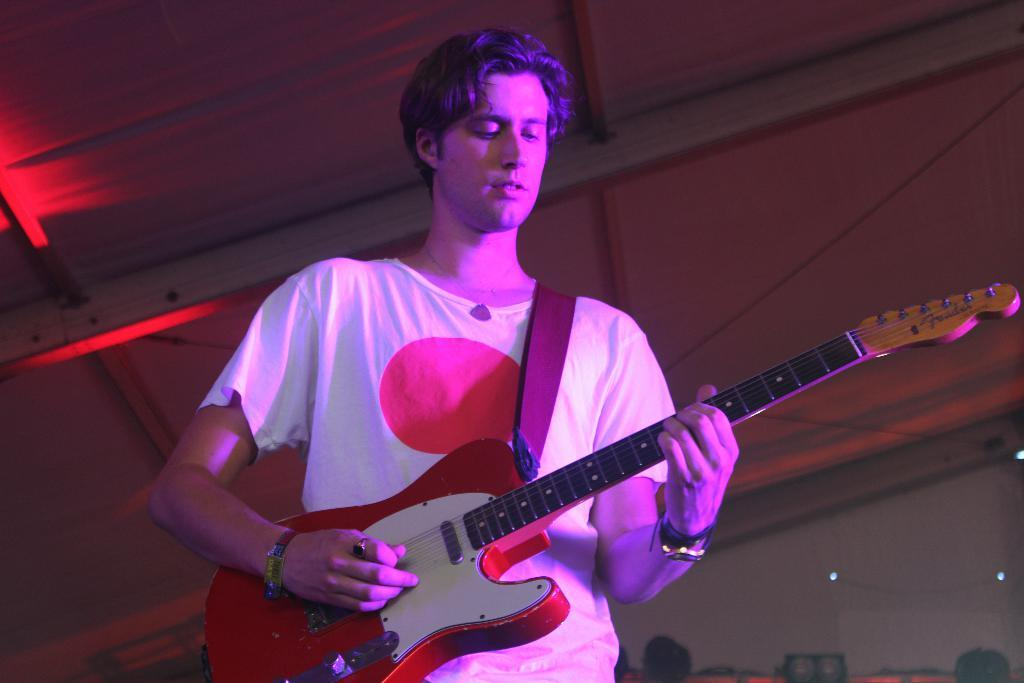What is the main subject of the image? The main subject of the image is a man. What is the man wearing in the image? The man is wearing a white t-shirt in the image. What activity is the man engaged in? The man is playing a guitar in the image. What type of cow can be seen attending the meeting in the image? There is no cow or meeting present in the image; it features a man playing a guitar. How many dogs are visible in the image? There are no dogs present in the image. 